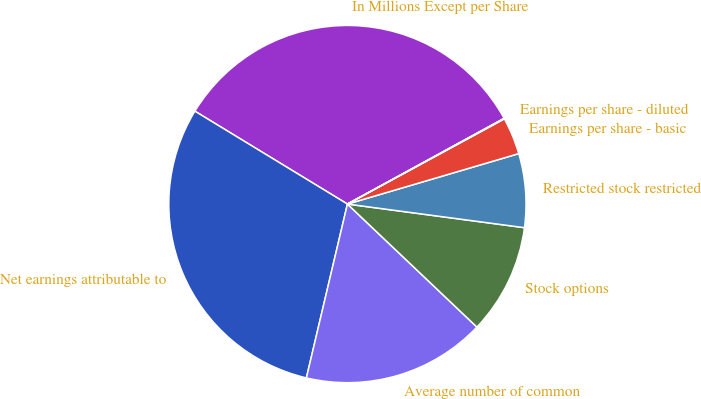Convert chart to OTSL. <chart><loc_0><loc_0><loc_500><loc_500><pie_chart><fcel>In Millions Except per Share<fcel>Net earnings attributable to<fcel>Average number of common<fcel>Stock options<fcel>Restricted stock restricted<fcel>Earnings per share - basic<fcel>Earnings per share - diluted<nl><fcel>33.33%<fcel>30.02%<fcel>16.6%<fcel>9.98%<fcel>6.67%<fcel>3.36%<fcel>0.05%<nl></chart> 